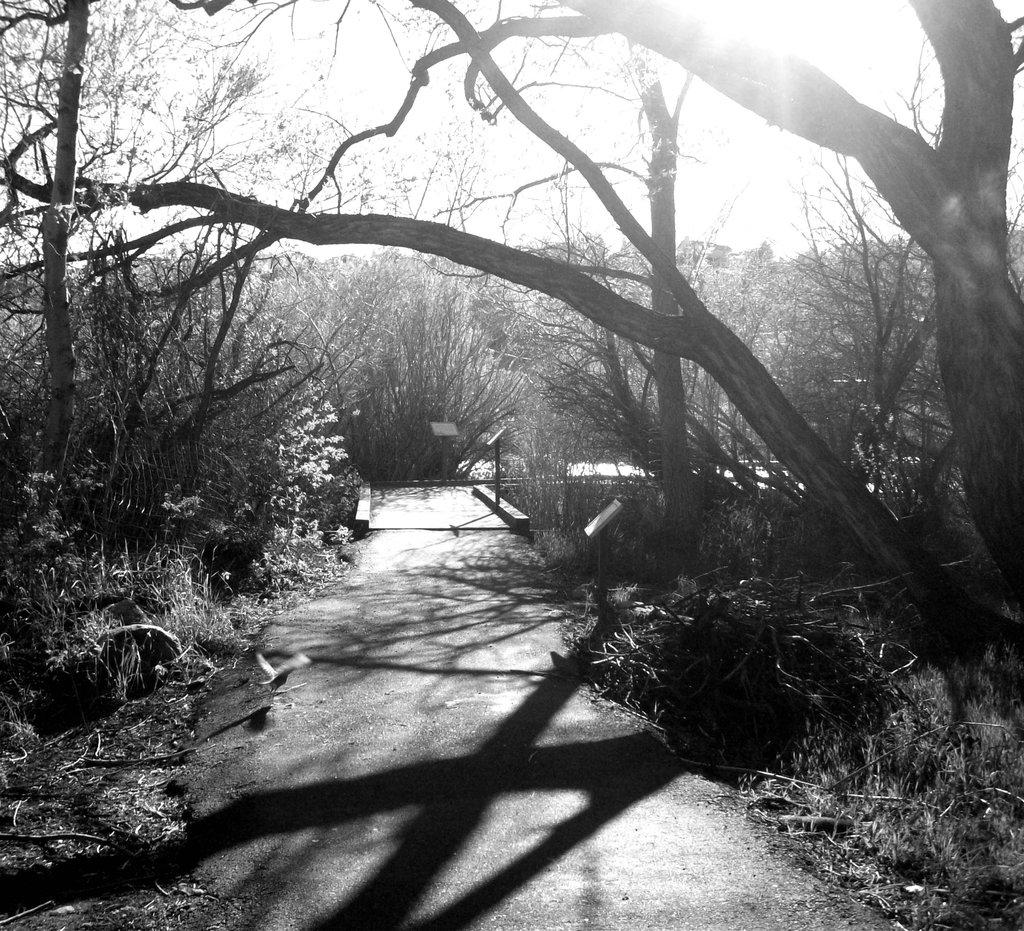What is the main feature of the image? There is a road in the image. What can be seen on both sides of the road? Trees and plants are present on both sides of the road. Where is the nearest hospital to the road in the image? The provided facts do not mention a hospital or its location, so it cannot be determined from the image. 